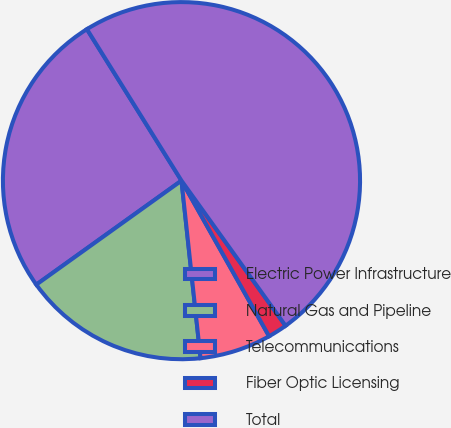Convert chart to OTSL. <chart><loc_0><loc_0><loc_500><loc_500><pie_chart><fcel>Electric Power Infrastructure<fcel>Natural Gas and Pipeline<fcel>Telecommunications<fcel>Fiber Optic Licensing<fcel>Total<nl><fcel>26.01%<fcel>16.81%<fcel>6.46%<fcel>1.74%<fcel>48.98%<nl></chart> 